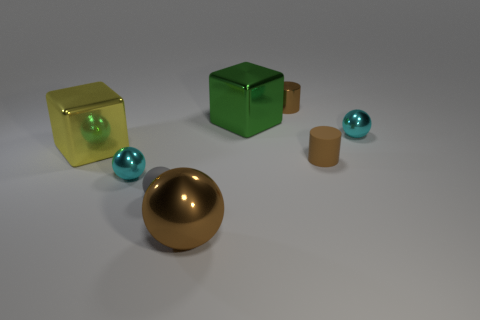Add 2 big spheres. How many objects exist? 10 Subtract all blocks. How many objects are left? 6 Subtract all large rubber cylinders. Subtract all small matte objects. How many objects are left? 6 Add 5 cylinders. How many cylinders are left? 7 Add 5 large yellow blocks. How many large yellow blocks exist? 6 Subtract 1 yellow blocks. How many objects are left? 7 